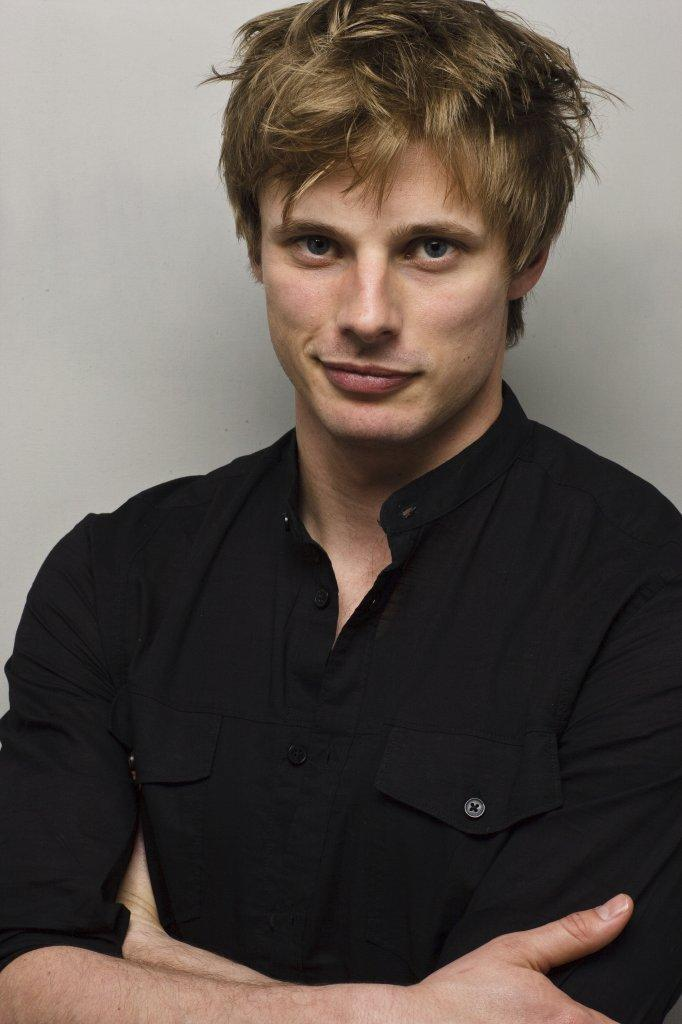Who is present in the image? There is a man in the image. What is the man wearing? The man is wearing a black shirt. What is the man doing in the image? The man is standing and smiling. What can be seen in the background of the image? There is a wall visible in the background of the image. What type of slave is depicted in the image? There is no slave present in the image; it features a man wearing a black shirt and standing with a smile. Is there any blood visible in the image? No, there is no blood present in the image. 